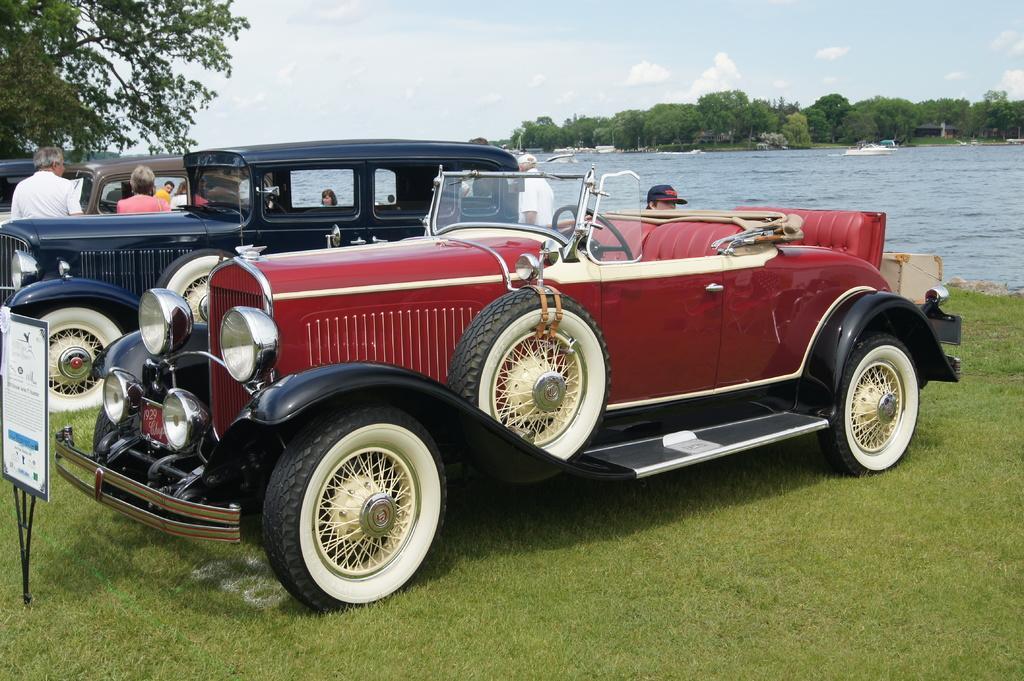Please provide a concise description of this image. In this picture we can see vehicles and a board on the ground, beside this ground we can see boats on water, here we can see people, grass and in the background we can see trees, sky and some objects. 